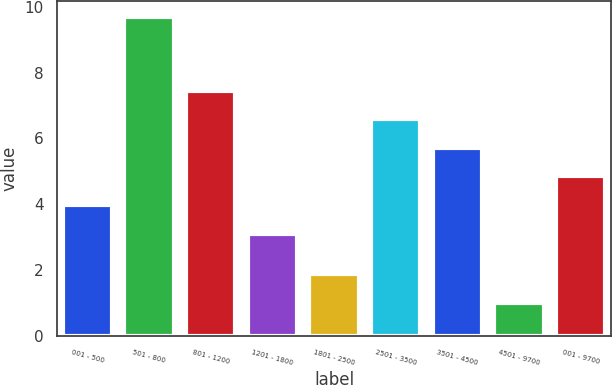<chart> <loc_0><loc_0><loc_500><loc_500><bar_chart><fcel>001 - 500<fcel>501 - 800<fcel>801 - 1200<fcel>1201 - 1800<fcel>1801 - 2500<fcel>2501 - 3500<fcel>3501 - 4500<fcel>4501 - 9700<fcel>001 - 9700<nl><fcel>3.97<fcel>9.7<fcel>7.45<fcel>3.1<fcel>1.87<fcel>6.58<fcel>5.71<fcel>1<fcel>4.84<nl></chart> 